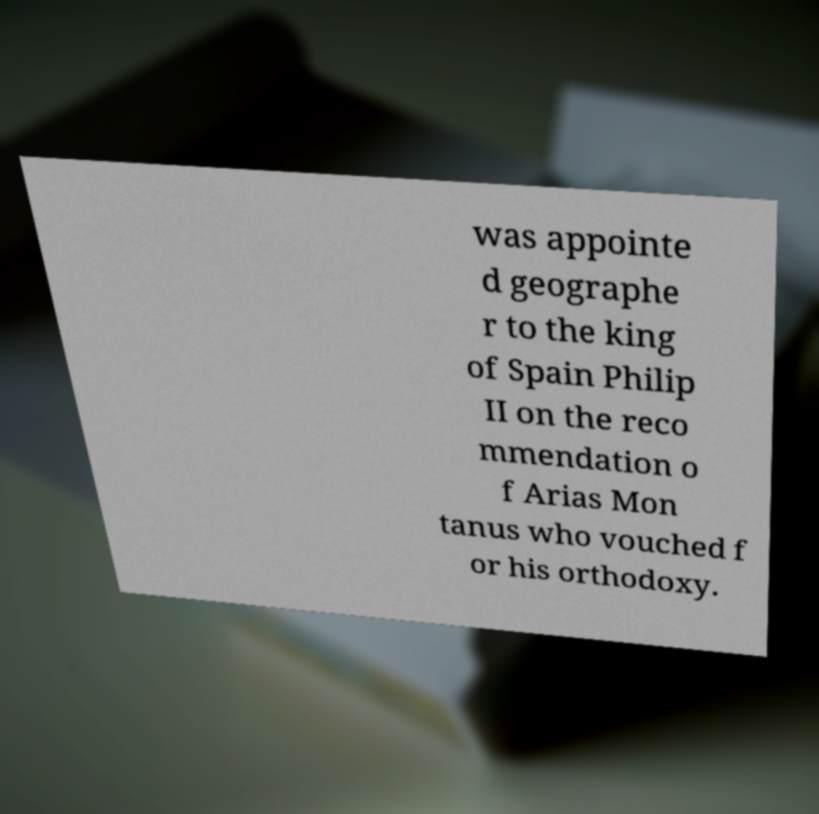Could you extract and type out the text from this image? was appointe d geographe r to the king of Spain Philip II on the reco mmendation o f Arias Mon tanus who vouched f or his orthodoxy. 